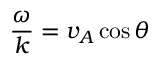<formula> <loc_0><loc_0><loc_500><loc_500>{ \frac { \omega } { k } } = v _ { A } \cos \theta</formula> 